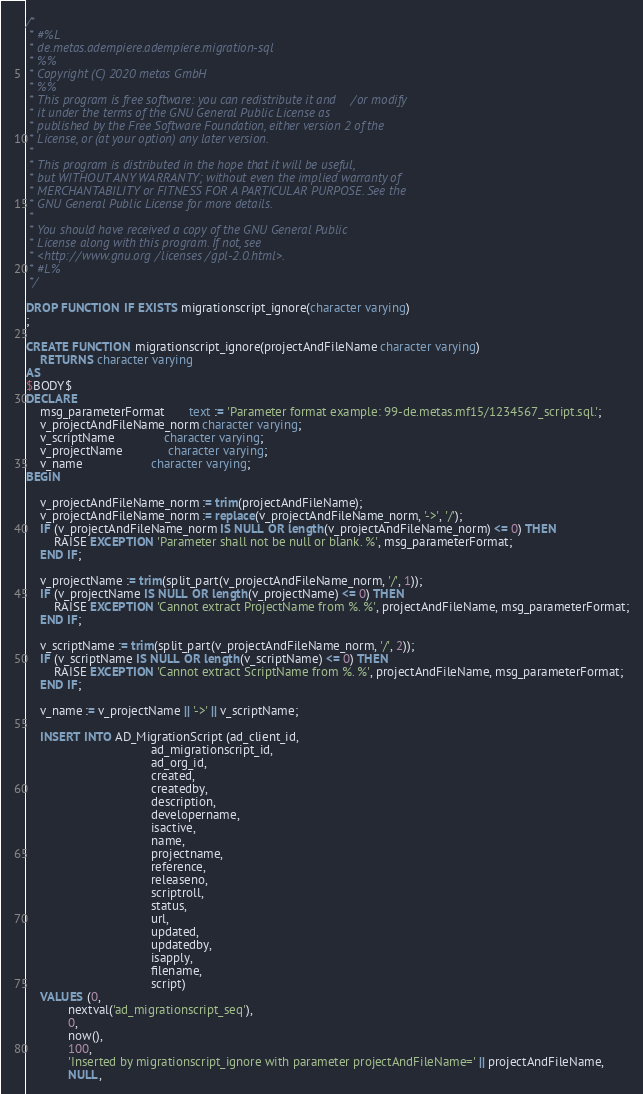<code> <loc_0><loc_0><loc_500><loc_500><_SQL_>/*
 * #%L
 * de.metas.adempiere.adempiere.migration-sql
 * %%
 * Copyright (C) 2020 metas GmbH
 * %%
 * This program is free software: you can redistribute it and/or modify
 * it under the terms of the GNU General Public License as
 * published by the Free Software Foundation, either version 2 of the
 * License, or (at your option) any later version.
 *
 * This program is distributed in the hope that it will be useful,
 * but WITHOUT ANY WARRANTY; without even the implied warranty of
 * MERCHANTABILITY or FITNESS FOR A PARTICULAR PURPOSE. See the
 * GNU General Public License for more details.
 *
 * You should have received a copy of the GNU General Public
 * License along with this program. If not, see
 * <http://www.gnu.org/licenses/gpl-2.0.html>.
 * #L%
 */

DROP FUNCTION IF EXISTS migrationscript_ignore(character varying)
;

CREATE FUNCTION migrationscript_ignore(projectAndFileName character varying)
    RETURNS character varying
AS
$BODY$
DECLARE
    msg_parameterFormat       text := 'Parameter format example: 99-de.metas.mf15/1234567_script.sql.';
    v_projectAndFileName_norm character varying;
    v_scriptName              character varying;
    v_projectName             character varying;
    v_name                    character varying;
BEGIN

    v_projectAndFileName_norm := trim(projectAndFileName);
    v_projectAndFileName_norm := replace(v_projectAndFileName_norm, '->', '/');
    IF (v_projectAndFileName_norm IS NULL OR length(v_projectAndFileName_norm) <= 0) THEN
        RAISE EXCEPTION 'Parameter shall not be null or blank. %', msg_parameterFormat;
    END IF;

    v_projectName := trim(split_part(v_projectAndFileName_norm, '/', 1));
    IF (v_projectName IS NULL OR length(v_projectName) <= 0) THEN
        RAISE EXCEPTION 'Cannot extract ProjectName from %. %', projectAndFileName, msg_parameterFormat;
    END IF;

    v_scriptName := trim(split_part(v_projectAndFileName_norm, '/', 2));
    IF (v_scriptName IS NULL OR length(v_scriptName) <= 0) THEN
        RAISE EXCEPTION 'Cannot extract ScriptName from %. %', projectAndFileName, msg_parameterFormat;
    END IF;

    v_name := v_projectName || '->' || v_scriptName;

    INSERT INTO AD_MigrationScript (ad_client_id,
                                    ad_migrationscript_id,
                                    ad_org_id,
                                    created,
                                    createdby,
                                    description,
                                    developername,
                                    isactive,
                                    name,
                                    projectname,
                                    reference,
                                    releaseno,
                                    scriptroll,
                                    status,
                                    url,
                                    updated,
                                    updatedby,
                                    isapply,
                                    filename,
                                    script)
    VALUES (0,
            nextval('ad_migrationscript_seq'),
            0,
            now(),
            100,
            'Inserted by migrationscript_ignore with parameter projectAndFileName=' || projectAndFileName,
            NULL,</code> 